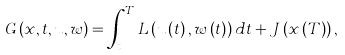Convert formula to latex. <formula><loc_0><loc_0><loc_500><loc_500>G \left ( x , t , u , w \right ) = \int _ { t } ^ { T } L \left ( u \left ( t \right ) , w \left ( t \right ) \right ) d t + J \left ( x \left ( T \right ) \right ) ,</formula> 